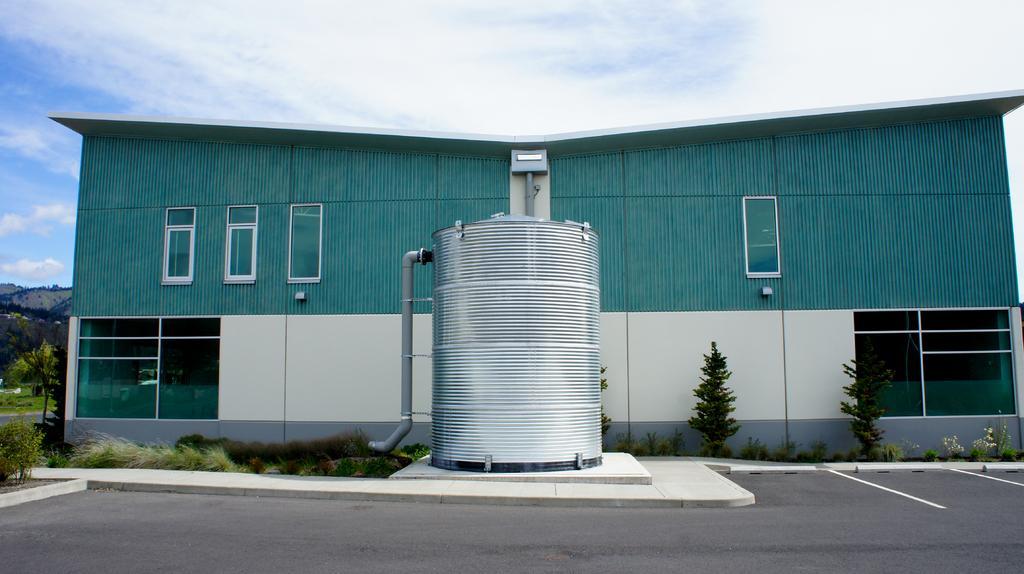Please provide a concise description of this image. In this image, I can see a building with the glass windows. In front of a building, I can see the plants, trees and a storage tank with a pipe. At the bottom of the image, this is a pathway. In the background, there are hills and the sky. 